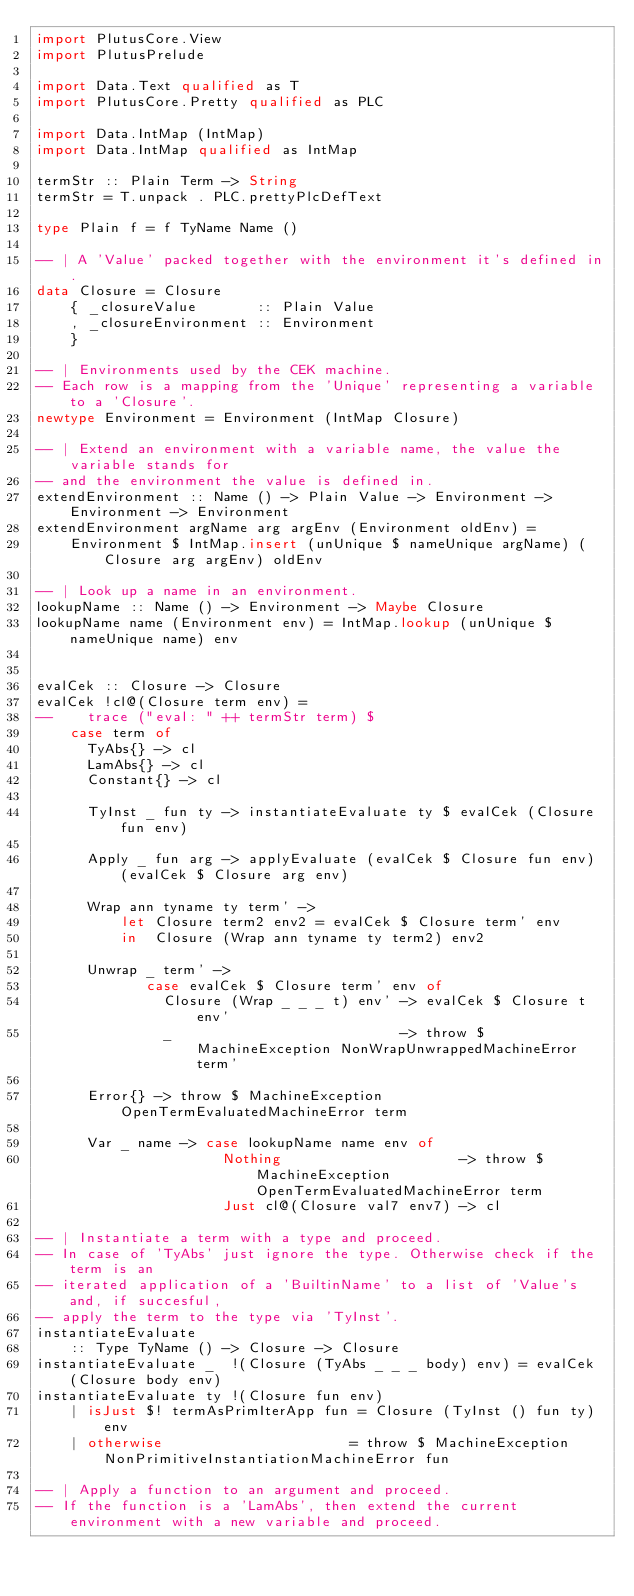Convert code to text. <code><loc_0><loc_0><loc_500><loc_500><_Haskell_>import PlutusCore.View
import PlutusPrelude

import Data.Text qualified as T
import PlutusCore.Pretty qualified as PLC

import Data.IntMap (IntMap)
import Data.IntMap qualified as IntMap

termStr :: Plain Term -> String
termStr = T.unpack . PLC.prettyPlcDefText

type Plain f = f TyName Name ()

-- | A 'Value' packed together with the environment it's defined in.
data Closure = Closure
    { _closureValue       :: Plain Value
    , _closureEnvironment :: Environment
    }

-- | Environments used by the CEK machine.
-- Each row is a mapping from the 'Unique' representing a variable to a 'Closure'.
newtype Environment = Environment (IntMap Closure)

-- | Extend an environment with a variable name, the value the variable stands for
-- and the environment the value is defined in.
extendEnvironment :: Name () -> Plain Value -> Environment -> Environment -> Environment
extendEnvironment argName arg argEnv (Environment oldEnv) =
    Environment $ IntMap.insert (unUnique $ nameUnique argName) (Closure arg argEnv) oldEnv

-- | Look up a name in an environment.
lookupName :: Name () -> Environment -> Maybe Closure
lookupName name (Environment env) = IntMap.lookup (unUnique $ nameUnique name) env


evalCek :: Closure -> Closure
evalCek !cl@(Closure term env) =
--    trace ("eval: " ++ termStr term) $
    case term of
      TyAbs{} -> cl
      LamAbs{} -> cl
      Constant{} -> cl

      TyInst _ fun ty -> instantiateEvaluate ty $ evalCek (Closure fun env)

      Apply _ fun arg -> applyEvaluate (evalCek $ Closure fun env) (evalCek $ Closure arg env)

      Wrap ann tyname ty term' ->
          let Closure term2 env2 = evalCek $ Closure term' env
          in  Closure (Wrap ann tyname ty term2) env2

      Unwrap _ term' ->
             case evalCek $ Closure term' env of
               Closure (Wrap _ _ _ t) env' -> evalCek $ Closure t env'
               _                           -> throw $ MachineException NonWrapUnwrappedMachineError term'

      Error{} -> throw $ MachineException OpenTermEvaluatedMachineError term

      Var _ name -> case lookupName name env of
                      Nothing                     -> throw $ MachineException OpenTermEvaluatedMachineError term
                      Just cl@(Closure val7 env7) -> cl

-- | Instantiate a term with a type and proceed.
-- In case of 'TyAbs' just ignore the type. Otherwise check if the term is an
-- iterated application of a 'BuiltinName' to a list of 'Value's and, if succesful,
-- apply the term to the type via 'TyInst'.
instantiateEvaluate
    :: Type TyName () -> Closure -> Closure
instantiateEvaluate _  !(Closure (TyAbs _ _ _ body) env) = evalCek (Closure body env)
instantiateEvaluate ty !(Closure fun env)
    | isJust $! termAsPrimIterApp fun = Closure (TyInst () fun ty) env
    | otherwise                      = throw $ MachineException NonPrimitiveInstantiationMachineError fun

-- | Apply a function to an argument and proceed.
-- If the function is a 'LamAbs', then extend the current environment with a new variable and proceed.</code> 